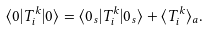Convert formula to latex. <formula><loc_0><loc_0><loc_500><loc_500>\langle 0 | T _ { i } ^ { k } | 0 \rangle = \langle 0 _ { s } | T _ { i } ^ { k } | 0 _ { s } \rangle + \langle T _ { i } ^ { k } \rangle _ { a } .</formula> 